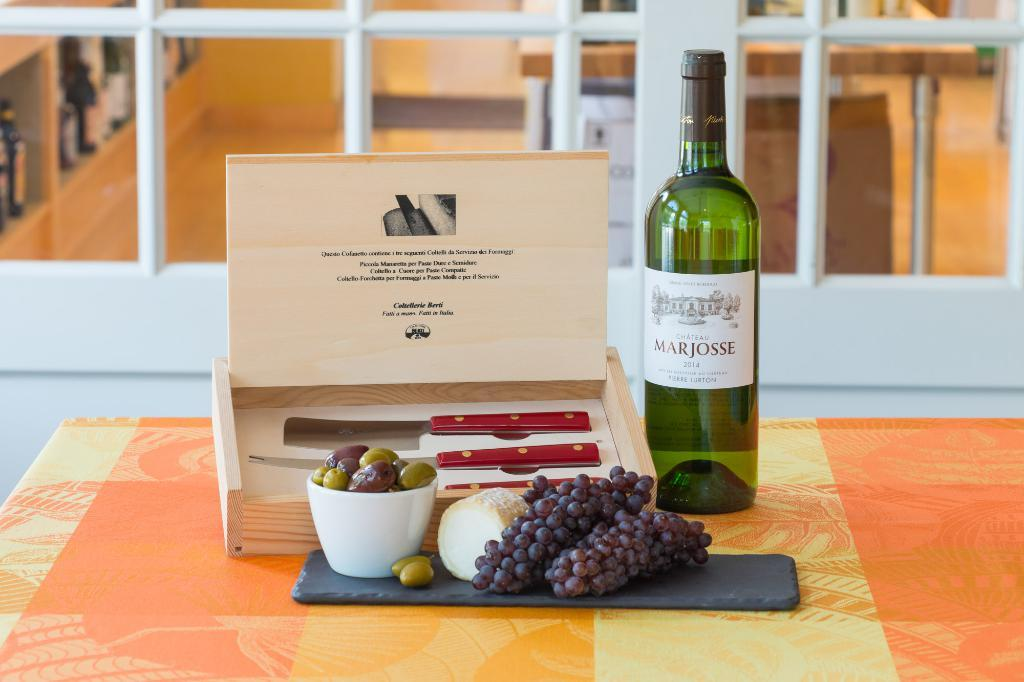<image>
Create a compact narrative representing the image presented. A wine bottle labeled Marjoss sits next to a box and grapes 